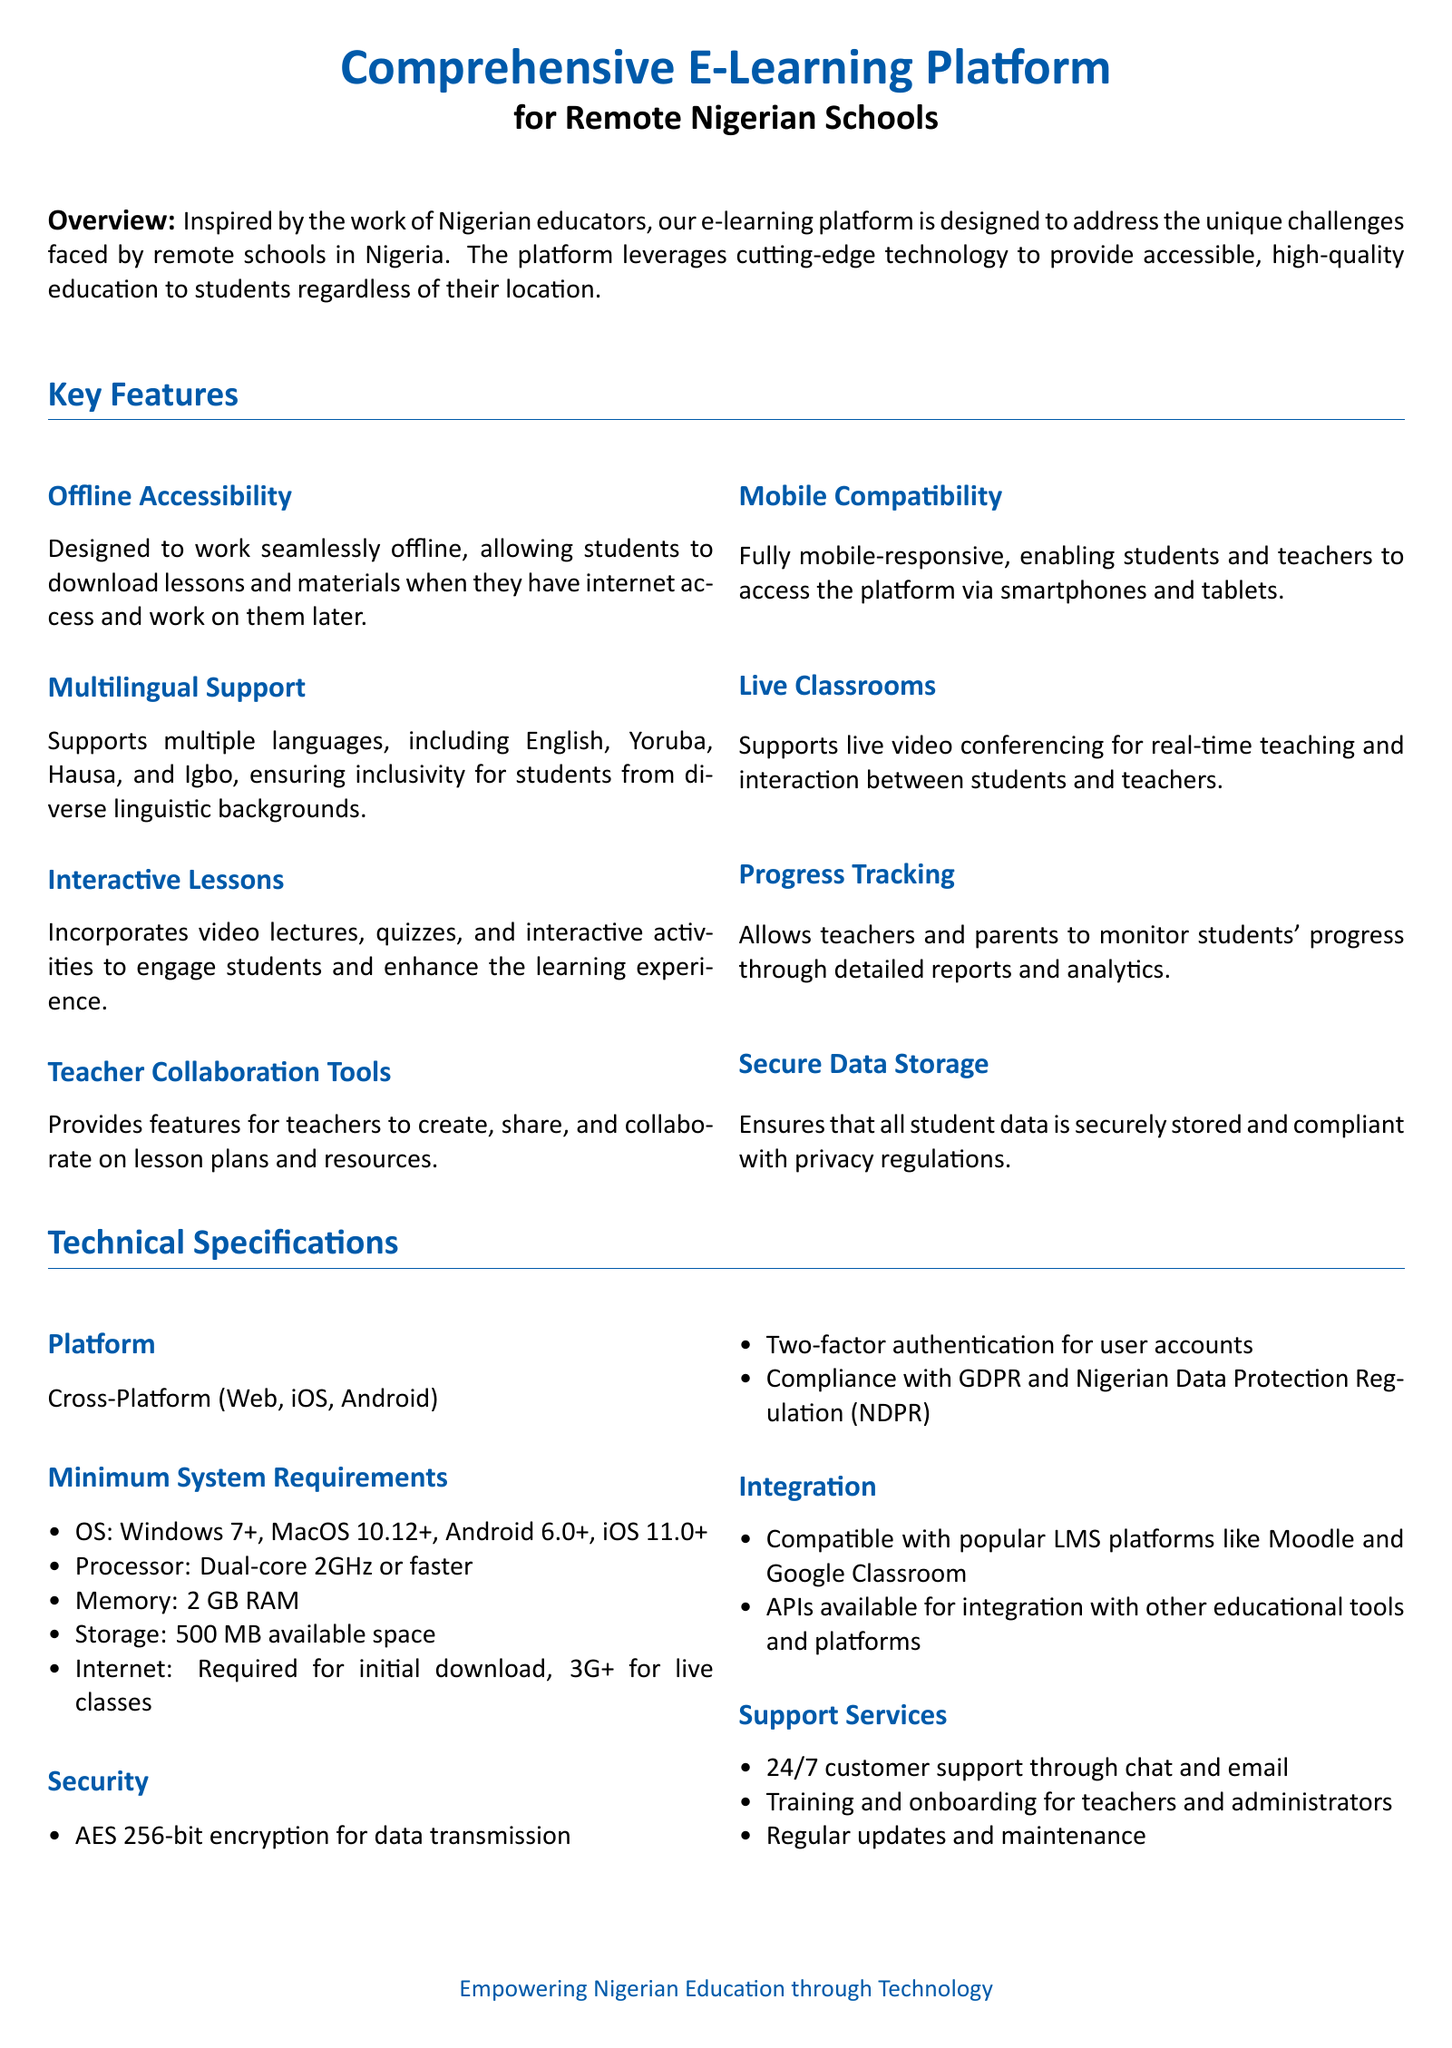What is the primary aim of the e-learning platform? The platform is designed to address the unique challenges faced by remote schools in Nigeria.
Answer: Address unique challenges How many languages does the platform support? The platform supports multiple languages, including English, Yoruba, Hausa, and Igbo.
Answer: Multiple languages What feature allows monitoring of student progress? The platform allows teachers and parents to monitor students' progress through detailed reports and analytics.
Answer: Progress Tracking What is the minimum RAM requirement? The document specifies the minimum system requirement for memory as 2 GB RAM.
Answer: 2 GB RAM What type of encryption is used for data transmission? The document states that AES 256-bit encryption is used for data transmission.
Answer: AES 256-bit Which platforms is the e-learning platform compatible with? The platform is compatible with popular LMS platforms like Moodle and Google Classroom.
Answer: Moodle and Google Classroom What type of support is offered to teachers? It includes training and onboarding for teachers and administrators.
Answer: Training and onboarding How does the platform ensure user account security? The platform ensures security through two-factor authentication for user accounts.
Answer: Two-factor authentication What is required for live classes to function? The document specifies that a 3G+ internet connection is required for live classes.
Answer: 3G+ 